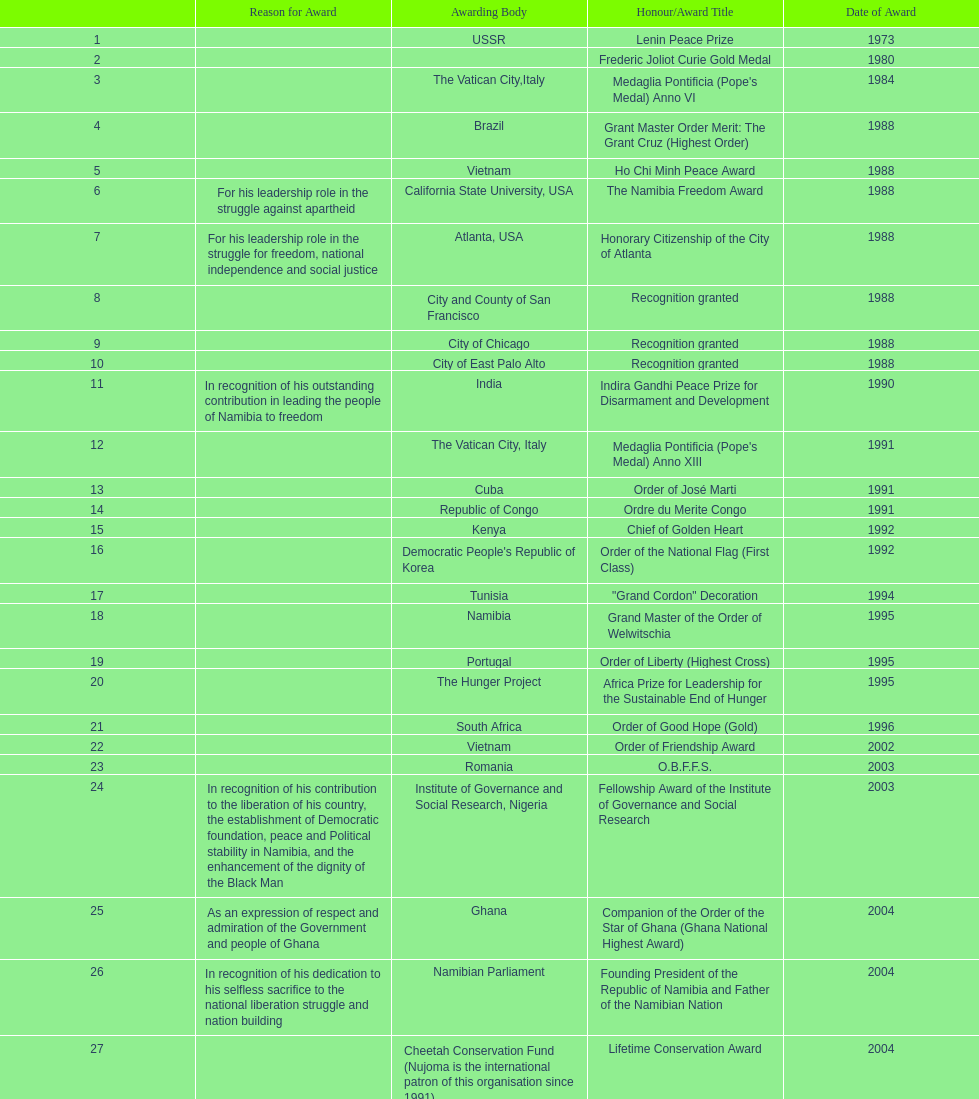What award was won previously just before the medaglia pontificia anno xiii was awarded? Indira Gandhi Peace Prize for Disarmament and Development. 